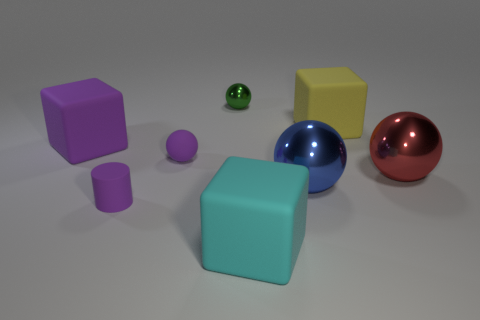Add 2 small purple metal blocks. How many objects exist? 10 Subtract all blocks. How many objects are left? 5 Add 5 small cyan objects. How many small cyan objects exist? 5 Subtract 0 brown blocks. How many objects are left? 8 Subtract all small purple cylinders. Subtract all big cyan matte things. How many objects are left? 6 Add 3 large red metallic spheres. How many large red metallic spheres are left? 4 